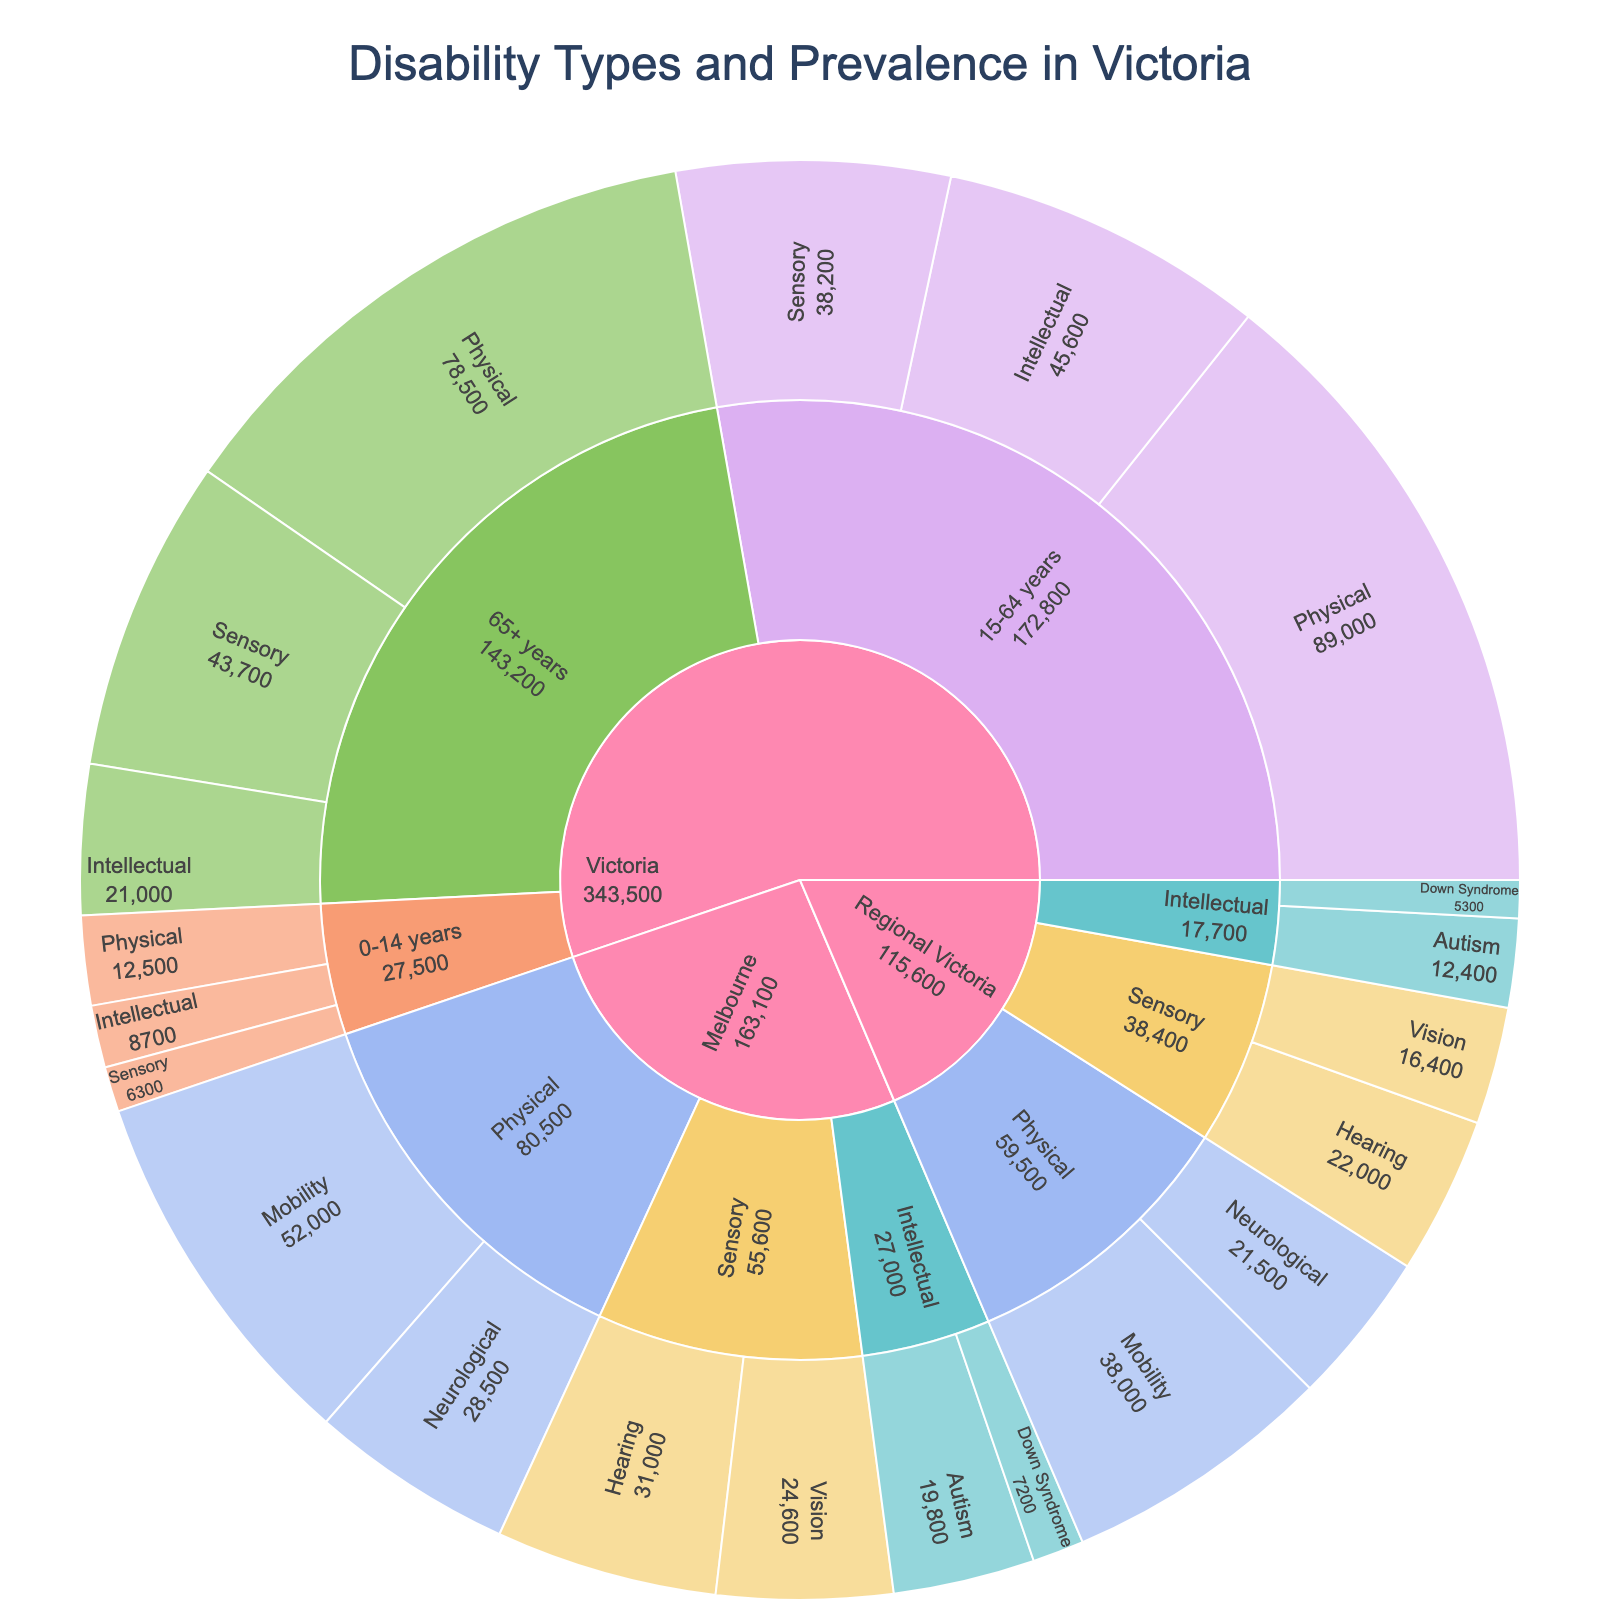What's the title of the figure? The title is usually displayed at the top of the sunburst plot. By looking at the top, you can see it reads "Disability Types and Prevalence in Victoria".
Answer: Disability Types and Prevalence in Victoria What disability type has the highest prevalence in the 15-64 years age group? To answer this, focus on the segment labeled "15-64 years" within the "Victoria" category, then see the values for each subcategory (Physical, Intellectual, Sensory). The highest value is 89000 for "Physical".
Answer: Physical Which region has a higher prevalence of Vision-related sensory disabilities, Melbourne or Regional Victoria? Look at the segments under the "Sensory" subcategory for both Melbourne and Regional Victoria. Melbourne's Vision-related disabilities are 24600 and Regional Victoria's are 16400. Therefore, Melbourne has the higher prevalence.
Answer: Melbourne What's the combined prevalence of Intellectual disabilities in the 0-14 years and 15-64 years age groups in Victoria? Sum the values for Intellectual disabilities in both the 0-14 years (8700) and 15-64 years (45600) age groups. The combined prevalence is 8700 + 45600 = 54300.
Answer: 54300 In the subcategory of Physical disabilities, which age group in Victoria shows the lowest prevalence? Look at the segments under "Physical" subcategory for all age groups (0-14 years, 15-64 years, 65+ years) in Victoria. The lowest value is 12500 for the 0-14 years group.
Answer: 0-14 years What is the difference in the number of people with Neurological disabilities between Melbourne and Regional Victoria? Find the segments under "Physical" subcategory and then "Neurological" for both regions. Melbourne has 28500 while Regional Victoria has 21500. The difference is 28500 - 21500 = 7000.
Answer: 7000 What's the most prevalent disability type in Regional Victoria? To find the most prevalent type in Regional Victoria, look at the highest value among the subcategories (Physical, Intellectual, Sensory) within the Regional Victoria segment. Physical has the highest value at 38000.
Answer: Physical How many more people have Down Syndrome in Melbourne compared to Regional Victoria? Look under the "Intellectual" subcategory and then "Down Syndrome" for both Melbourne and Regional Victoria. Melbourne has 7200, and Regional Victoria has 5300. The difference is 7200 - 5300 = 1900.
Answer: 1900 Which age group in Victoria has the highest total number of disabilities? To answer this, sum the values of all disability types within each age group (0-14 years, 15-64 years, 65+ years) and compare. The sums are 12500+8700+6300=27500 for 0-14 years, 89000+45600+38200=172800 for 15-64 years, and 78500+21000+43700=143200 for 65+ years. The age group 15-64 years has the highest total.
Answer: 15-64 years What is the total prevalence of Sensory disabilities in Victoria across all age groups? Sum the values of Sensory disabilities for all age groups (0-14 years, 15-64 years, 65+ years) in Victoria. The sums are 6300 + 38200 + 43700 = 88200.
Answer: 88200 